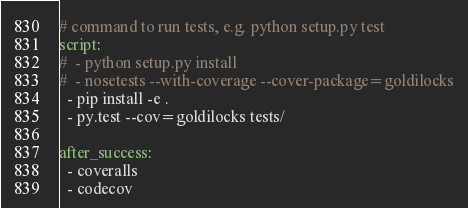<code> <loc_0><loc_0><loc_500><loc_500><_YAML_># command to run tests, e.g. python setup.py test
script:
#  - python setup.py install
#  - nosetests --with-coverage --cover-package=goldilocks
  - pip install -e .
  - py.test --cov=goldilocks tests/

after_success:
  - coveralls
  - codecov
</code> 